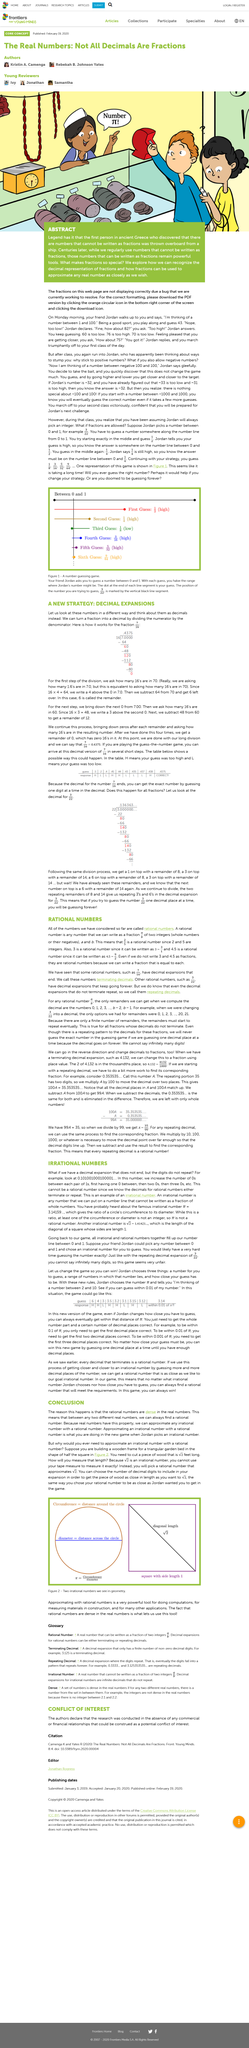Mention a couple of crucial points in this snapshot. What is your sixth guess? Nine divided by sixty-four is approximately 0.13333333333333335, which is a decimal value. The bottom figure shows a fraction that is equivalent to 3/22. Repeating decimals are rational numbers that have decimal expansions that continue indefinitely and repeatedly. The top figure shows a fraction that is equal to 7/16. What is your initial estimate? A rough guess of 0.5 is suggested... 